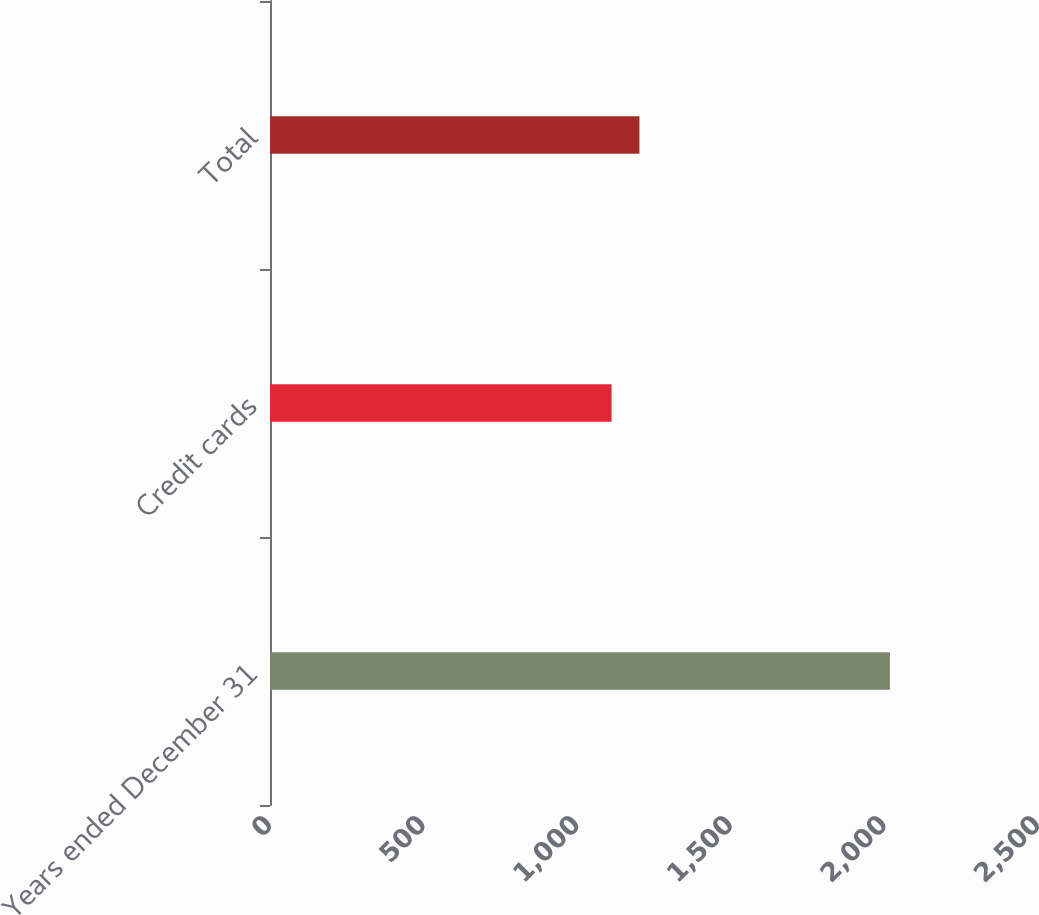Convert chart to OTSL. <chart><loc_0><loc_0><loc_500><loc_500><bar_chart><fcel>Years ended December 31<fcel>Credit cards<fcel>Total<nl><fcel>2018<fcel>1112<fcel>1202.6<nl></chart> 